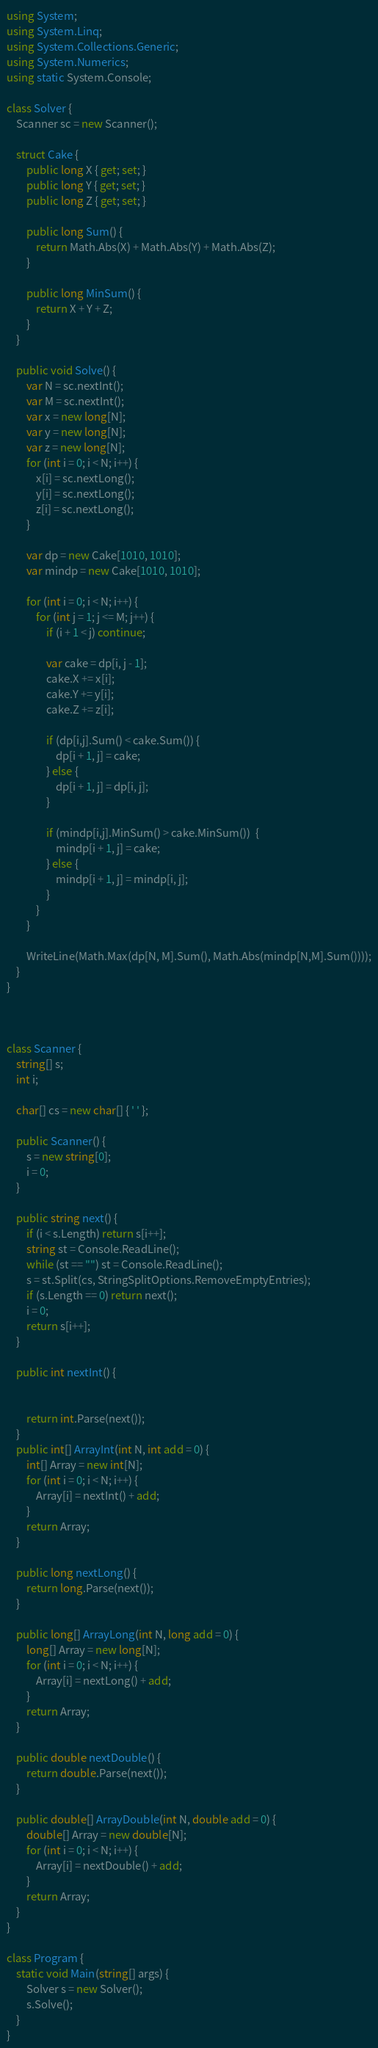Convert code to text. <code><loc_0><loc_0><loc_500><loc_500><_C#_>using System;
using System.Linq;
using System.Collections.Generic;
using System.Numerics;
using static System.Console;

class Solver {
    Scanner sc = new Scanner();

    struct Cake {
        public long X { get; set; }
        public long Y { get; set; }
        public long Z { get; set; }

        public long Sum() {
            return Math.Abs(X) + Math.Abs(Y) + Math.Abs(Z);
        }

        public long MinSum() {
            return X + Y + Z;
        }
    }

    public void Solve() {
        var N = sc.nextInt();
        var M = sc.nextInt();
        var x = new long[N];
        var y = new long[N];
        var z = new long[N];
        for (int i = 0; i < N; i++) {
            x[i] = sc.nextLong();
            y[i] = sc.nextLong();
            z[i] = sc.nextLong();
        }

        var dp = new Cake[1010, 1010];
        var mindp = new Cake[1010, 1010];

        for (int i = 0; i < N; i++) {
            for (int j = 1; j <= M; j++) {
                if (i + 1 < j) continue;

                var cake = dp[i, j - 1];
                cake.X += x[i];
                cake.Y += y[i];
                cake.Z += z[i];

                if (dp[i,j].Sum() < cake.Sum()) {
                    dp[i + 1, j] = cake;
                } else {
                    dp[i + 1, j] = dp[i, j];
                }

                if (mindp[i,j].MinSum() > cake.MinSum())  {
                    mindp[i + 1, j] = cake;
                } else {
                    mindp[i + 1, j] = mindp[i, j];
                }
            }
        }

        WriteLine(Math.Max(dp[N, M].Sum(), Math.Abs(mindp[N,M].Sum())));
    }
}



class Scanner {
    string[] s;
    int i;

    char[] cs = new char[] { ' ' };

    public Scanner() {
        s = new string[0];
        i = 0;
    }

    public string next() {
        if (i < s.Length) return s[i++];
        string st = Console.ReadLine();
        while (st == "") st = Console.ReadLine();
        s = st.Split(cs, StringSplitOptions.RemoveEmptyEntries);
        if (s.Length == 0) return next();
        i = 0;
        return s[i++];
    }

    public int nextInt() {


        return int.Parse(next());
    }
    public int[] ArrayInt(int N, int add = 0) {
        int[] Array = new int[N];
        for (int i = 0; i < N; i++) {
            Array[i] = nextInt() + add;
        }
        return Array;
    }

    public long nextLong() {
        return long.Parse(next());
    }

    public long[] ArrayLong(int N, long add = 0) {
        long[] Array = new long[N];
        for (int i = 0; i < N; i++) {
            Array[i] = nextLong() + add;
        }
        return Array;
    }

    public double nextDouble() {
        return double.Parse(next());
    }

    public double[] ArrayDouble(int N, double add = 0) {
        double[] Array = new double[N];
        for (int i = 0; i < N; i++) {
            Array[i] = nextDouble() + add;
        }
        return Array;
    }
}

class Program {
    static void Main(string[] args) {
        Solver s = new Solver();
        s.Solve();
    }
}</code> 